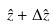Convert formula to latex. <formula><loc_0><loc_0><loc_500><loc_500>\hat { z } + \Delta \hat { z }</formula> 